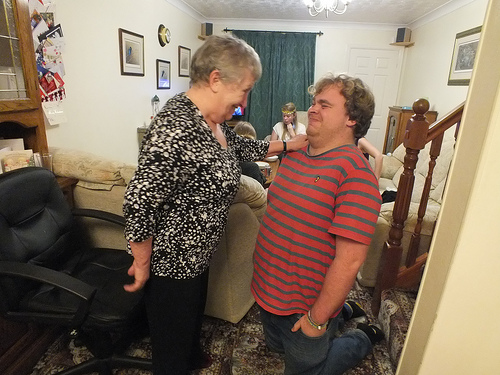<image>
Is the old lady in front of the man? Yes. The old lady is positioned in front of the man, appearing closer to the camera viewpoint. Is the man above the staircase? No. The man is not positioned above the staircase. The vertical arrangement shows a different relationship. 